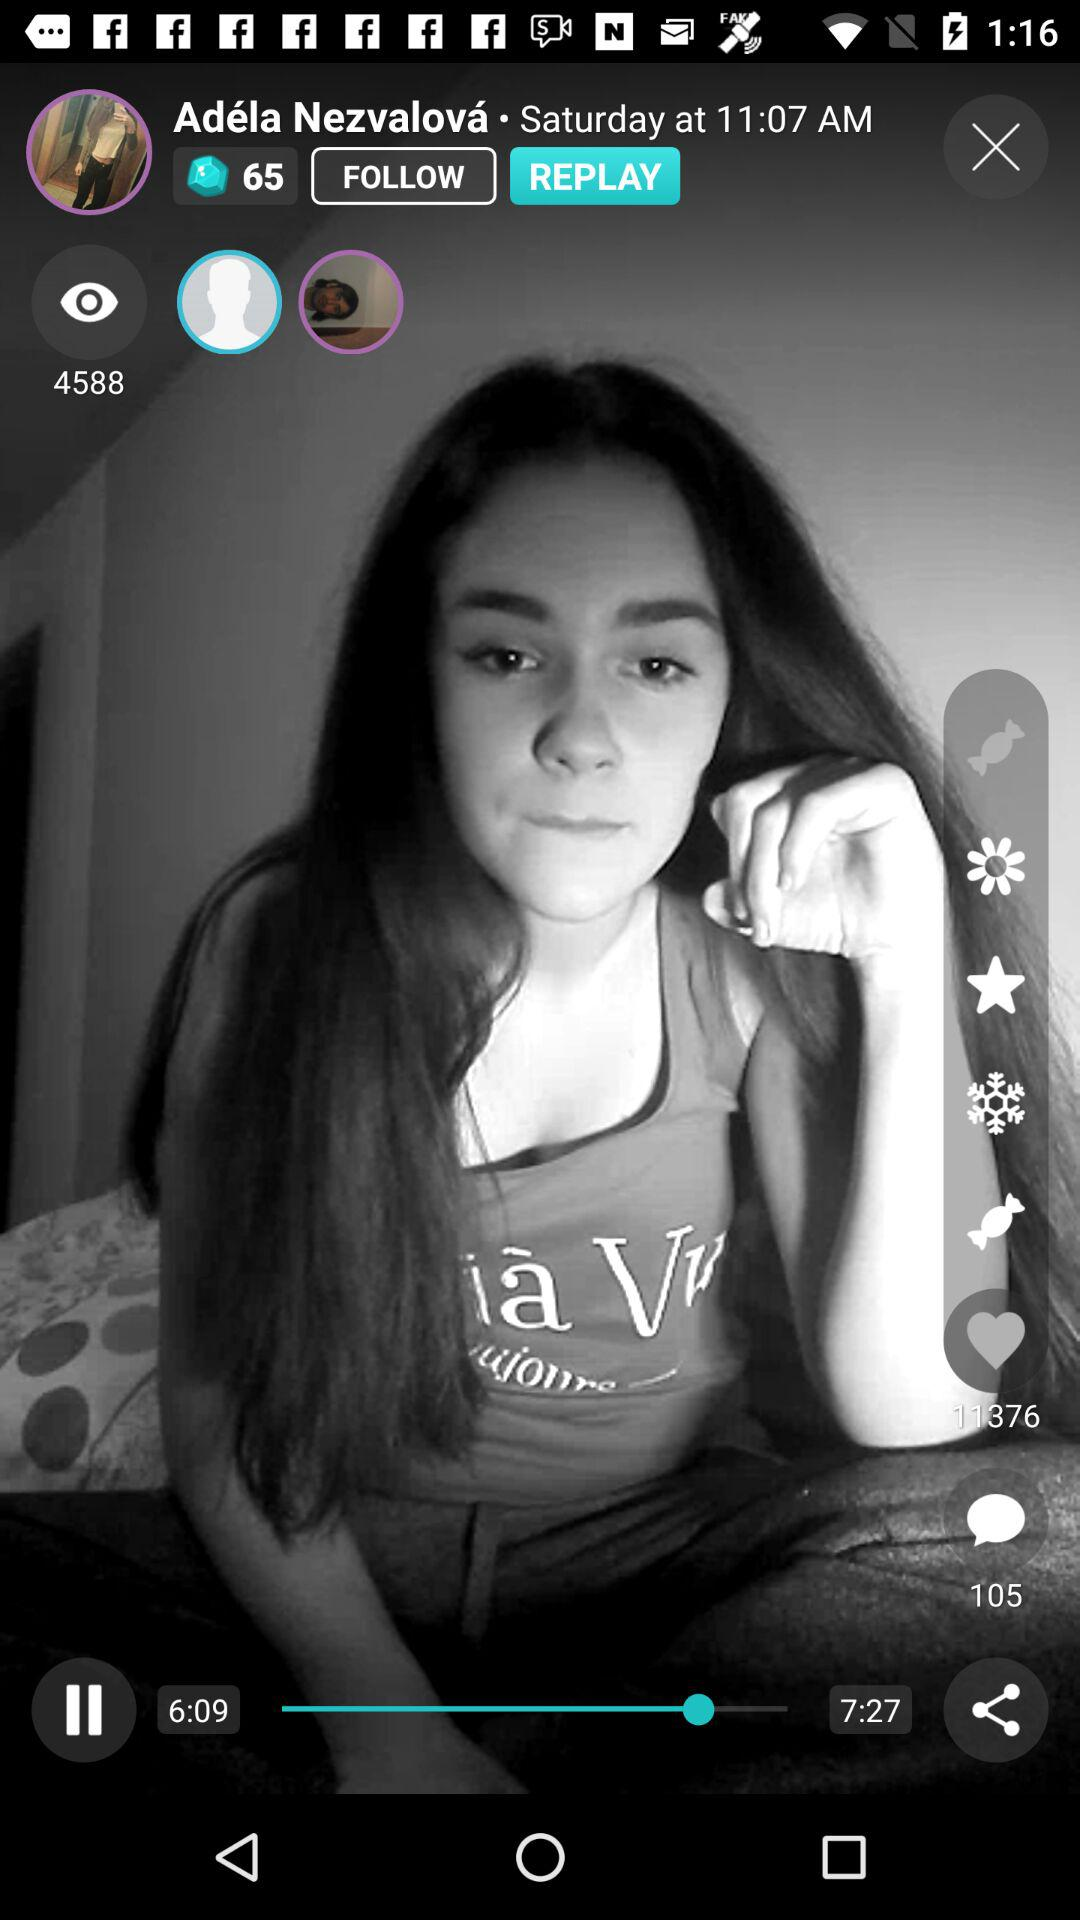What is the name? The name is "Adela Nezvalova". 